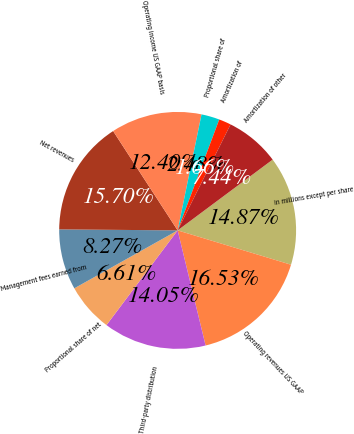<chart> <loc_0><loc_0><loc_500><loc_500><pie_chart><fcel>in millions except per share<fcel>Operating revenues US GAAP<fcel>Third-party distribution<fcel>Proportional share of net<fcel>Management fees earned from<fcel>Net revenues<fcel>Operating income US GAAP basis<fcel>Proportional share of<fcel>Amortization of<fcel>Amortization of other<nl><fcel>14.87%<fcel>16.53%<fcel>14.05%<fcel>6.61%<fcel>8.27%<fcel>15.7%<fcel>12.4%<fcel>2.48%<fcel>1.66%<fcel>7.44%<nl></chart> 